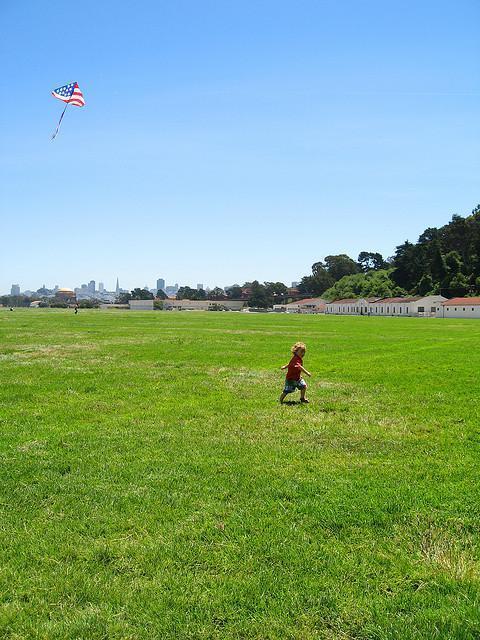How many kites are flying?
Give a very brief answer. 1. How many chairs are there?
Give a very brief answer. 0. 